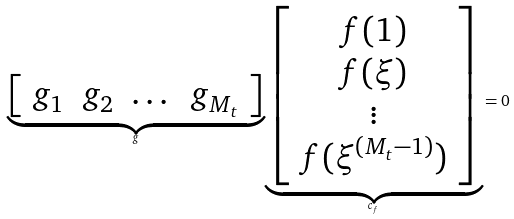<formula> <loc_0><loc_0><loc_500><loc_500>\underbrace { \left [ \begin{array} { c c c c } g _ { 1 } & g _ { 2 } & \dots & g _ { M _ { t } } \end{array} \right ] } _ { g } \underbrace { \left [ \begin{array} { c } f ( 1 ) \\ f ( \xi ) \\ \vdots \\ f ( \xi ^ { ( M _ { t } - 1 ) } ) \end{array} \right ] } _ { c _ { f } } & = 0</formula> 